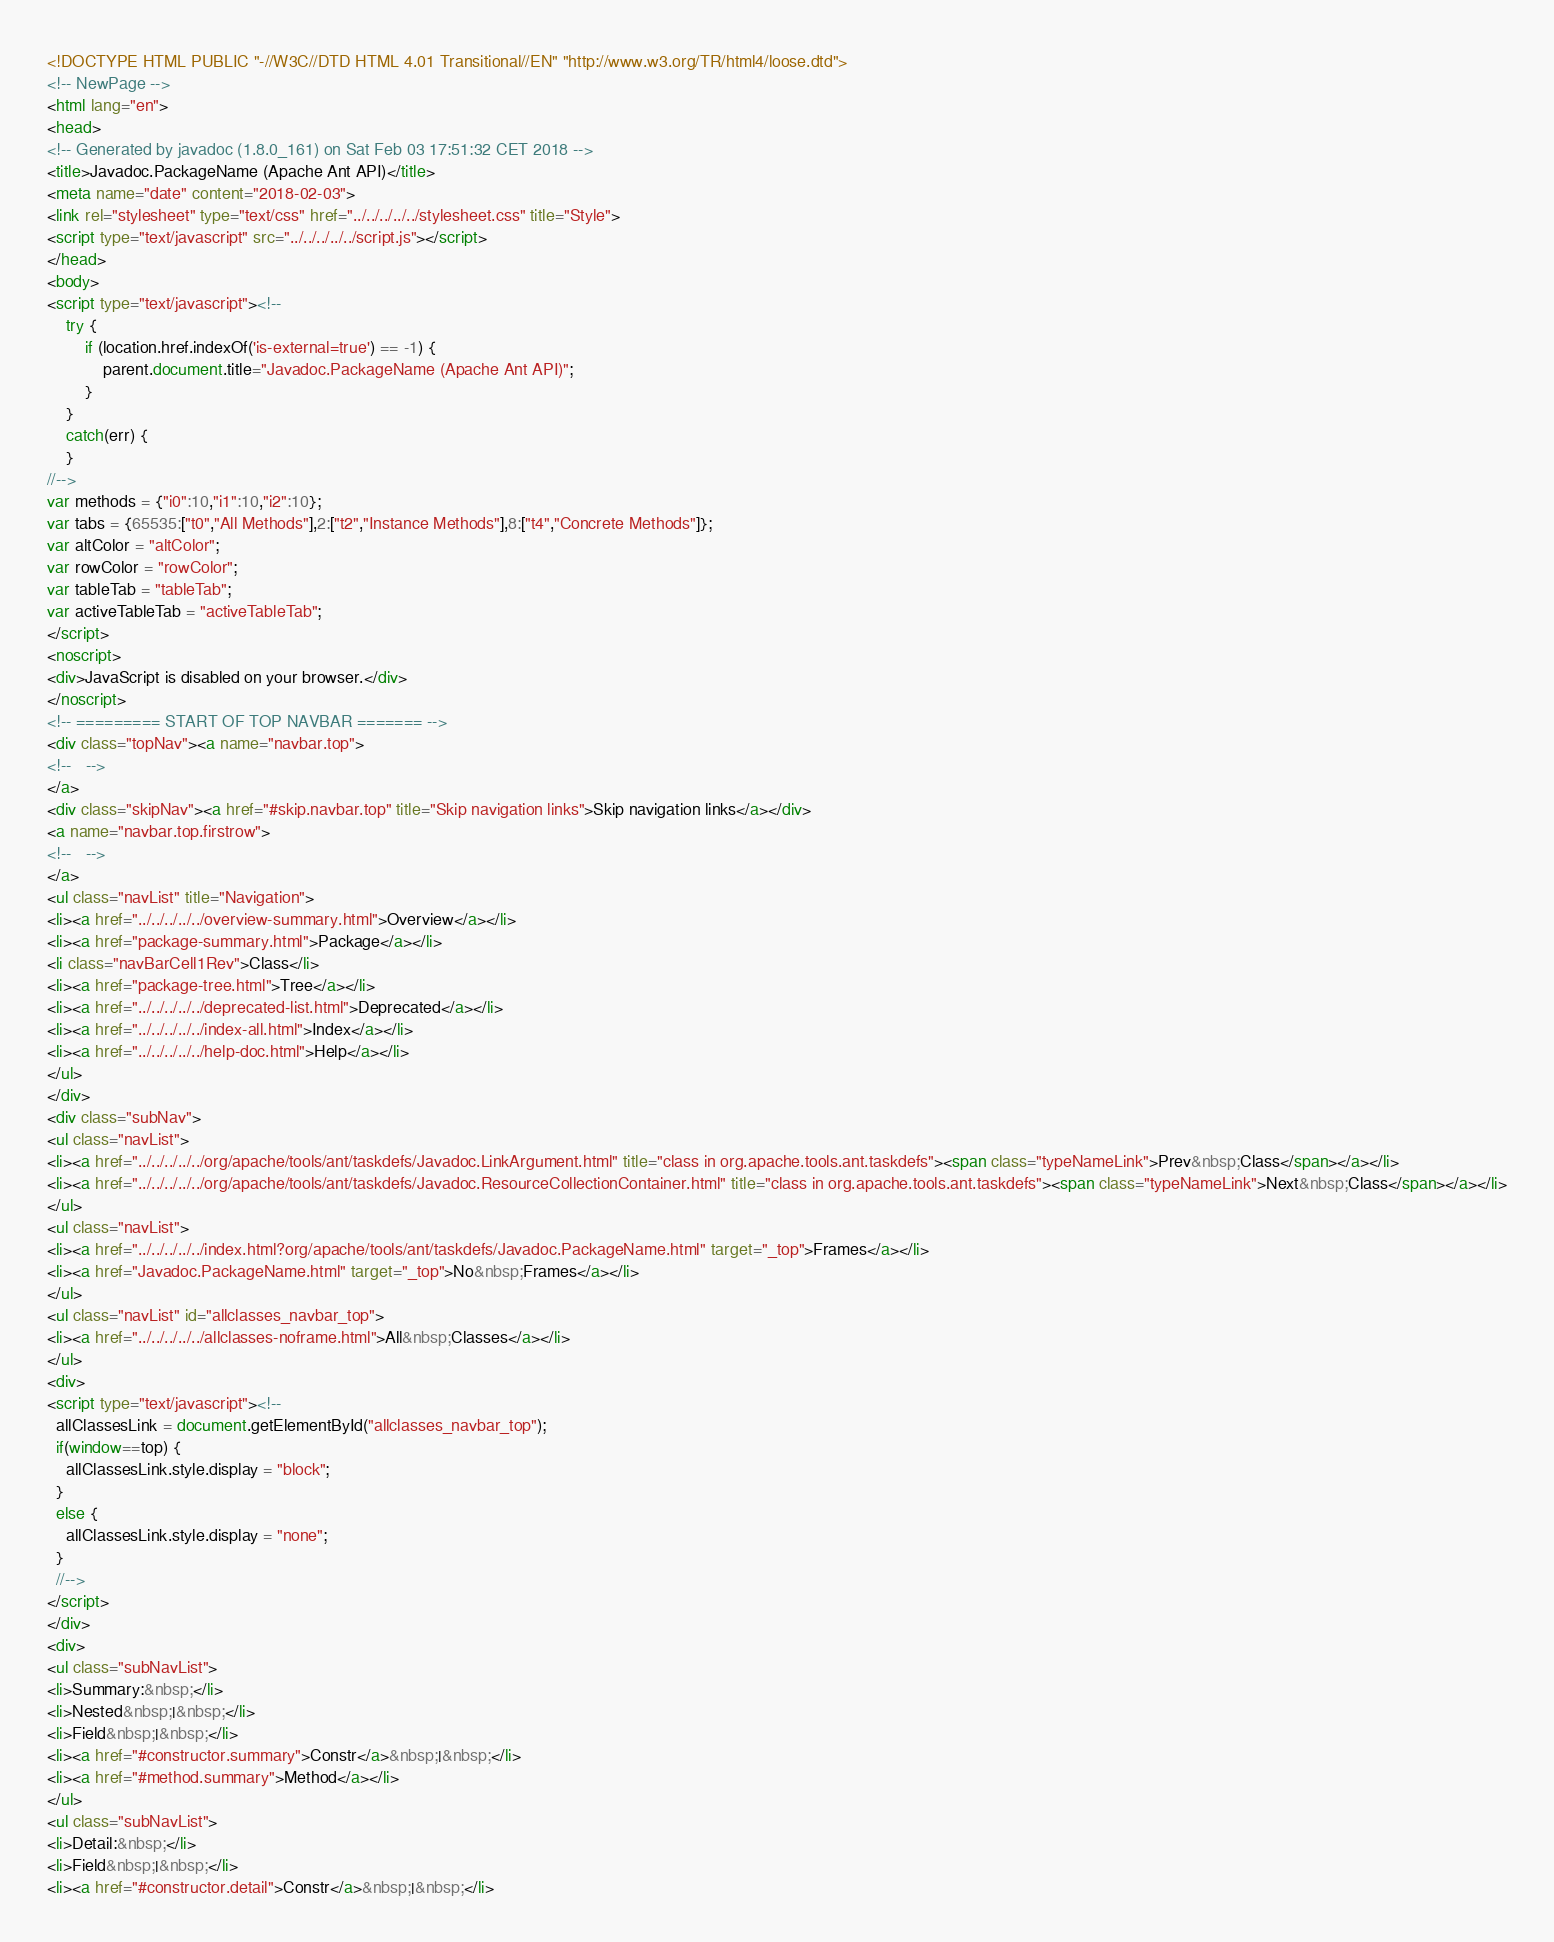Convert code to text. <code><loc_0><loc_0><loc_500><loc_500><_HTML_><!DOCTYPE HTML PUBLIC "-//W3C//DTD HTML 4.01 Transitional//EN" "http://www.w3.org/TR/html4/loose.dtd">
<!-- NewPage -->
<html lang="en">
<head>
<!-- Generated by javadoc (1.8.0_161) on Sat Feb 03 17:51:32 CET 2018 -->
<title>Javadoc.PackageName (Apache Ant API)</title>
<meta name="date" content="2018-02-03">
<link rel="stylesheet" type="text/css" href="../../../../../stylesheet.css" title="Style">
<script type="text/javascript" src="../../../../../script.js"></script>
</head>
<body>
<script type="text/javascript"><!--
    try {
        if (location.href.indexOf('is-external=true') == -1) {
            parent.document.title="Javadoc.PackageName (Apache Ant API)";
        }
    }
    catch(err) {
    }
//-->
var methods = {"i0":10,"i1":10,"i2":10};
var tabs = {65535:["t0","All Methods"],2:["t2","Instance Methods"],8:["t4","Concrete Methods"]};
var altColor = "altColor";
var rowColor = "rowColor";
var tableTab = "tableTab";
var activeTableTab = "activeTableTab";
</script>
<noscript>
<div>JavaScript is disabled on your browser.</div>
</noscript>
<!-- ========= START OF TOP NAVBAR ======= -->
<div class="topNav"><a name="navbar.top">
<!--   -->
</a>
<div class="skipNav"><a href="#skip.navbar.top" title="Skip navigation links">Skip navigation links</a></div>
<a name="navbar.top.firstrow">
<!--   -->
</a>
<ul class="navList" title="Navigation">
<li><a href="../../../../../overview-summary.html">Overview</a></li>
<li><a href="package-summary.html">Package</a></li>
<li class="navBarCell1Rev">Class</li>
<li><a href="package-tree.html">Tree</a></li>
<li><a href="../../../../../deprecated-list.html">Deprecated</a></li>
<li><a href="../../../../../index-all.html">Index</a></li>
<li><a href="../../../../../help-doc.html">Help</a></li>
</ul>
</div>
<div class="subNav">
<ul class="navList">
<li><a href="../../../../../org/apache/tools/ant/taskdefs/Javadoc.LinkArgument.html" title="class in org.apache.tools.ant.taskdefs"><span class="typeNameLink">Prev&nbsp;Class</span></a></li>
<li><a href="../../../../../org/apache/tools/ant/taskdefs/Javadoc.ResourceCollectionContainer.html" title="class in org.apache.tools.ant.taskdefs"><span class="typeNameLink">Next&nbsp;Class</span></a></li>
</ul>
<ul class="navList">
<li><a href="../../../../../index.html?org/apache/tools/ant/taskdefs/Javadoc.PackageName.html" target="_top">Frames</a></li>
<li><a href="Javadoc.PackageName.html" target="_top">No&nbsp;Frames</a></li>
</ul>
<ul class="navList" id="allclasses_navbar_top">
<li><a href="../../../../../allclasses-noframe.html">All&nbsp;Classes</a></li>
</ul>
<div>
<script type="text/javascript"><!--
  allClassesLink = document.getElementById("allclasses_navbar_top");
  if(window==top) {
    allClassesLink.style.display = "block";
  }
  else {
    allClassesLink.style.display = "none";
  }
  //-->
</script>
</div>
<div>
<ul class="subNavList">
<li>Summary:&nbsp;</li>
<li>Nested&nbsp;|&nbsp;</li>
<li>Field&nbsp;|&nbsp;</li>
<li><a href="#constructor.summary">Constr</a>&nbsp;|&nbsp;</li>
<li><a href="#method.summary">Method</a></li>
</ul>
<ul class="subNavList">
<li>Detail:&nbsp;</li>
<li>Field&nbsp;|&nbsp;</li>
<li><a href="#constructor.detail">Constr</a>&nbsp;|&nbsp;</li></code> 